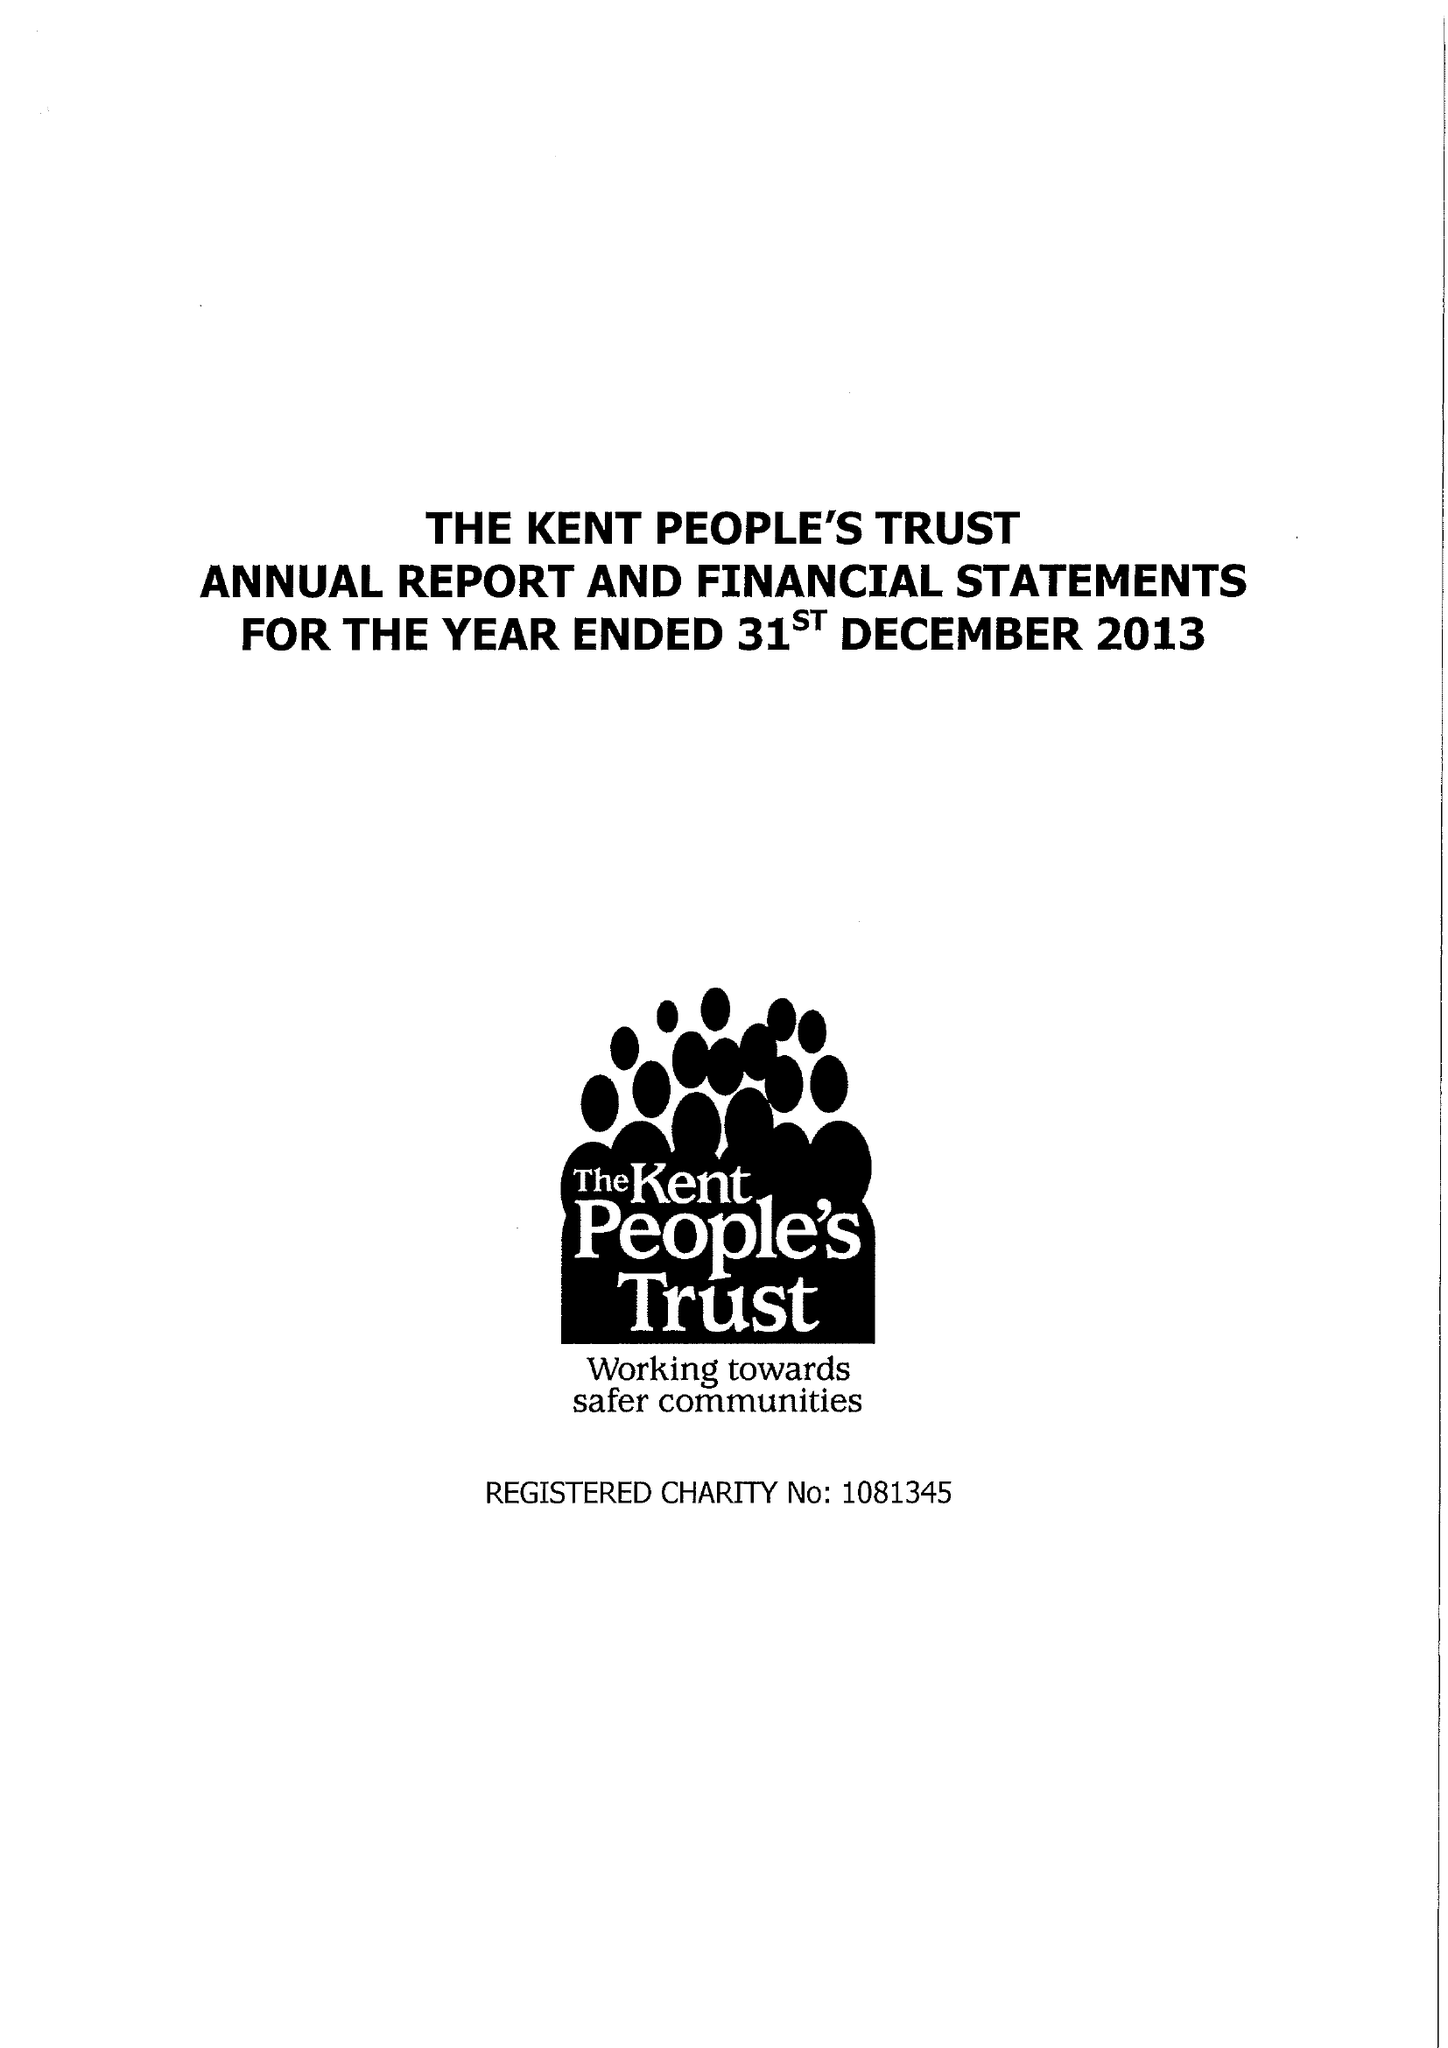What is the value for the charity_name?
Answer the question using a single word or phrase. The Kent People's Trust 